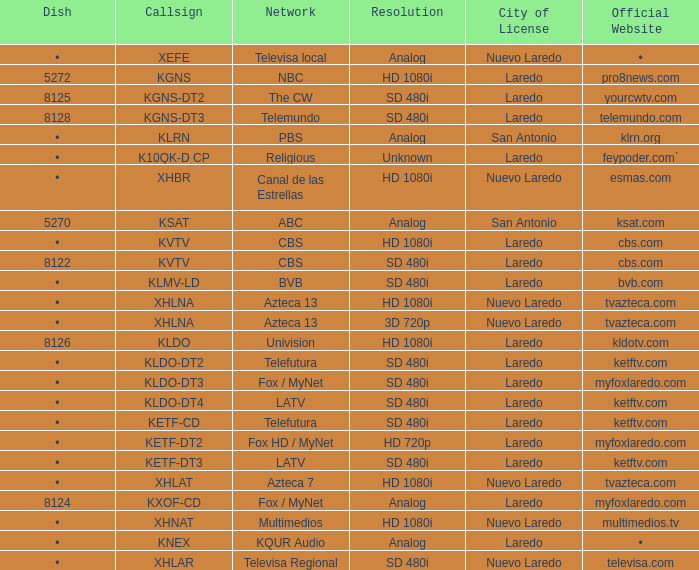What is the resolution of ketftv.com and the callsign for kldo-dt2? SD 480i. 